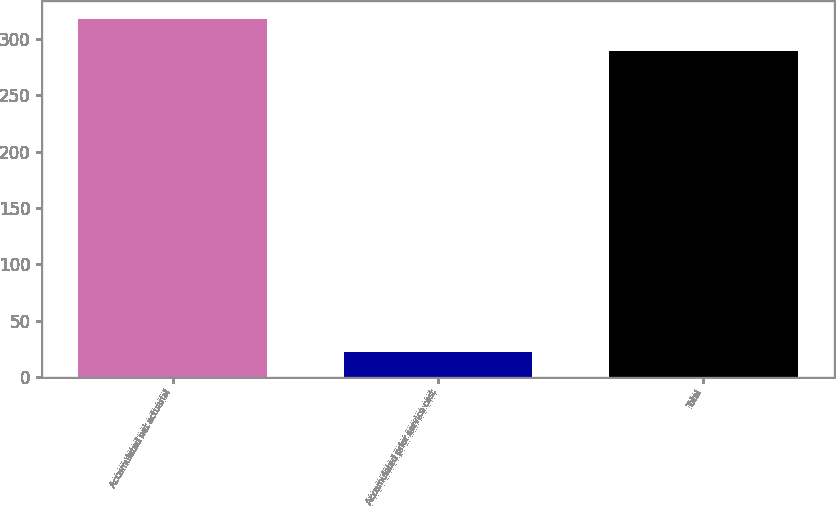<chart> <loc_0><loc_0><loc_500><loc_500><bar_chart><fcel>Accumulated net actuarial<fcel>Accumulated prior service cost<fcel>Total<nl><fcel>317.9<fcel>22<fcel>289<nl></chart> 